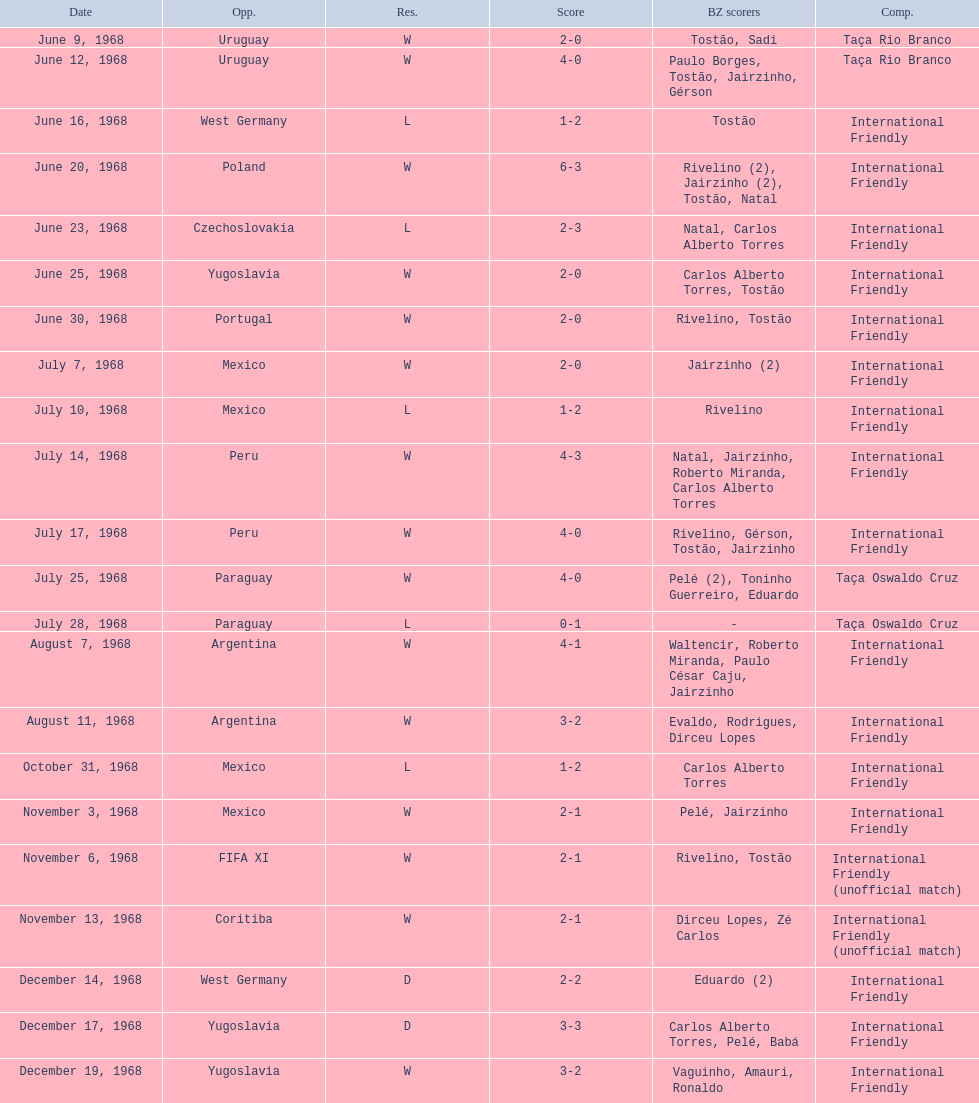How many times did brazil score during the game on november 6th? 2. 